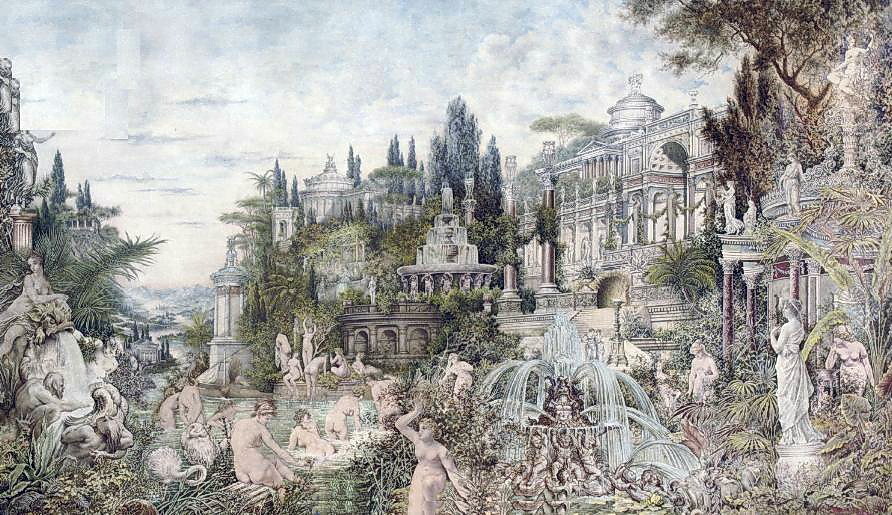What might be the historical significance of the architectural style seen in the palace? The palace's architectural style is reminiscent of the Rococo era, which flourished in Europe during the early 18th century. This style is known for its elaborate ornamentation, intricate sculptures, and complex forms, often conveying a sense of movement and asymmetry. The historical significance lies in its reflection of the social and cultural aspirations of the aristocracy during a period of relative peace and prosperity, emphasizing art, personal enjoyment, and the beauty of nature. 